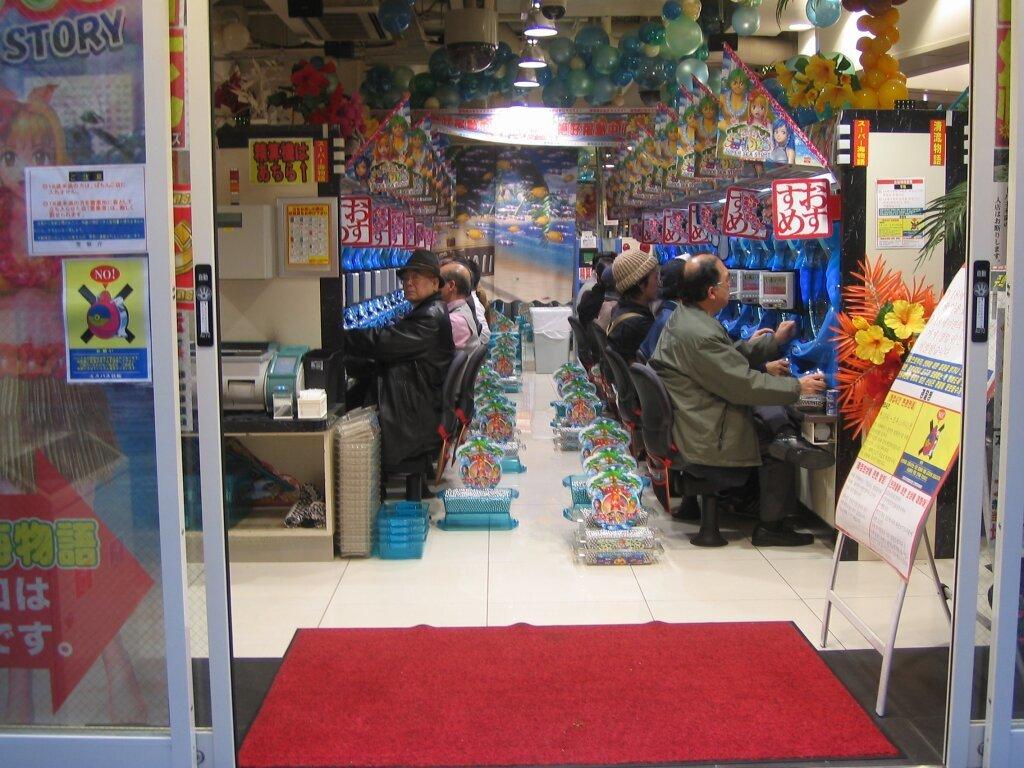What word is on the front glass above the anime character?
Your answer should be compact. Story. 